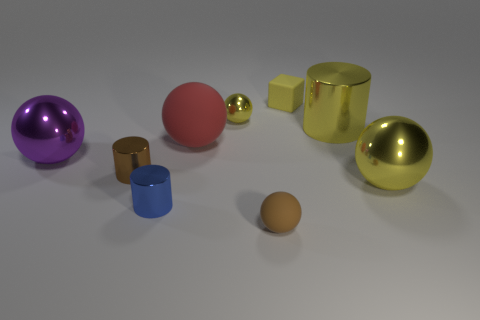Subtract all green blocks. How many yellow balls are left? 2 Subtract all big purple spheres. How many spheres are left? 4 Subtract 3 balls. How many balls are left? 2 Subtract all yellow balls. How many balls are left? 3 Subtract all cubes. How many objects are left? 8 Add 6 big yellow metal balls. How many big yellow metal balls exist? 7 Subtract 1 purple balls. How many objects are left? 8 Subtract all purple cylinders. Subtract all red cubes. How many cylinders are left? 3 Subtract all cylinders. Subtract all metallic objects. How many objects are left? 0 Add 8 purple things. How many purple things are left? 9 